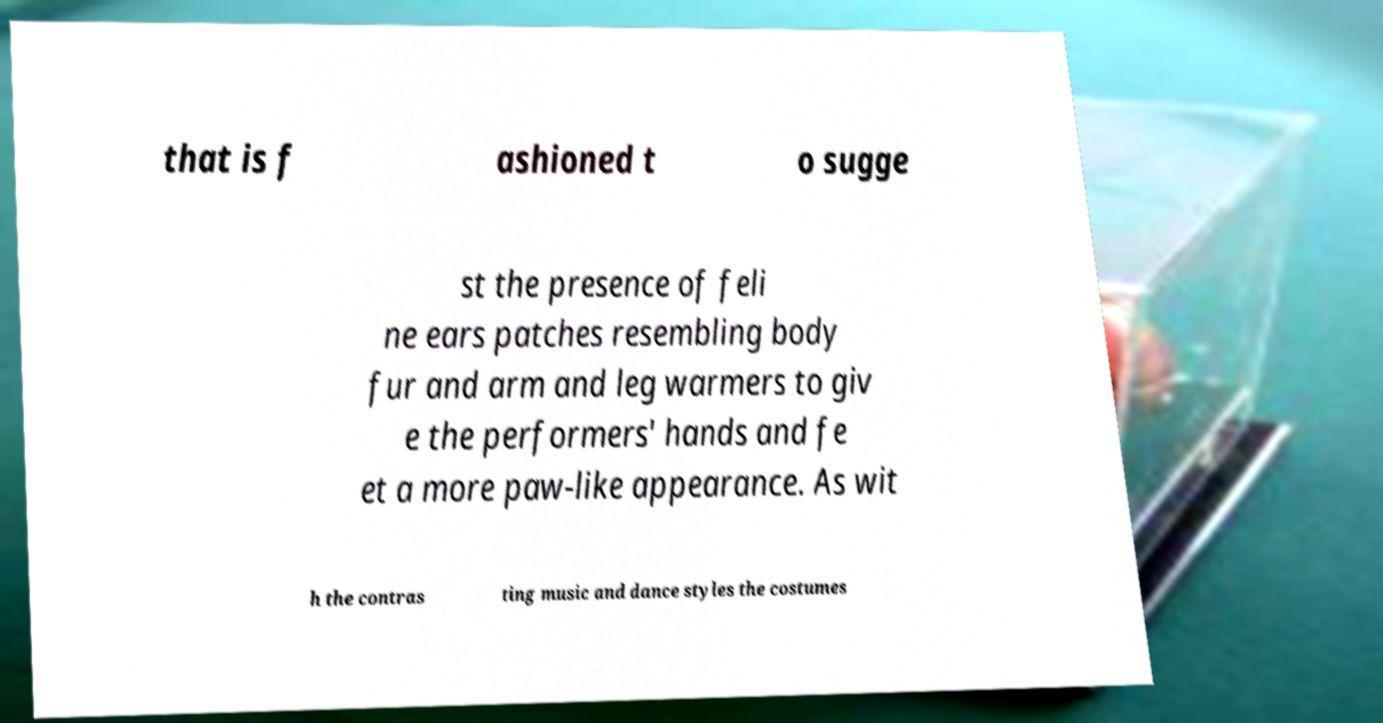Please identify and transcribe the text found in this image. that is f ashioned t o sugge st the presence of feli ne ears patches resembling body fur and arm and leg warmers to giv e the performers' hands and fe et a more paw-like appearance. As wit h the contras ting music and dance styles the costumes 